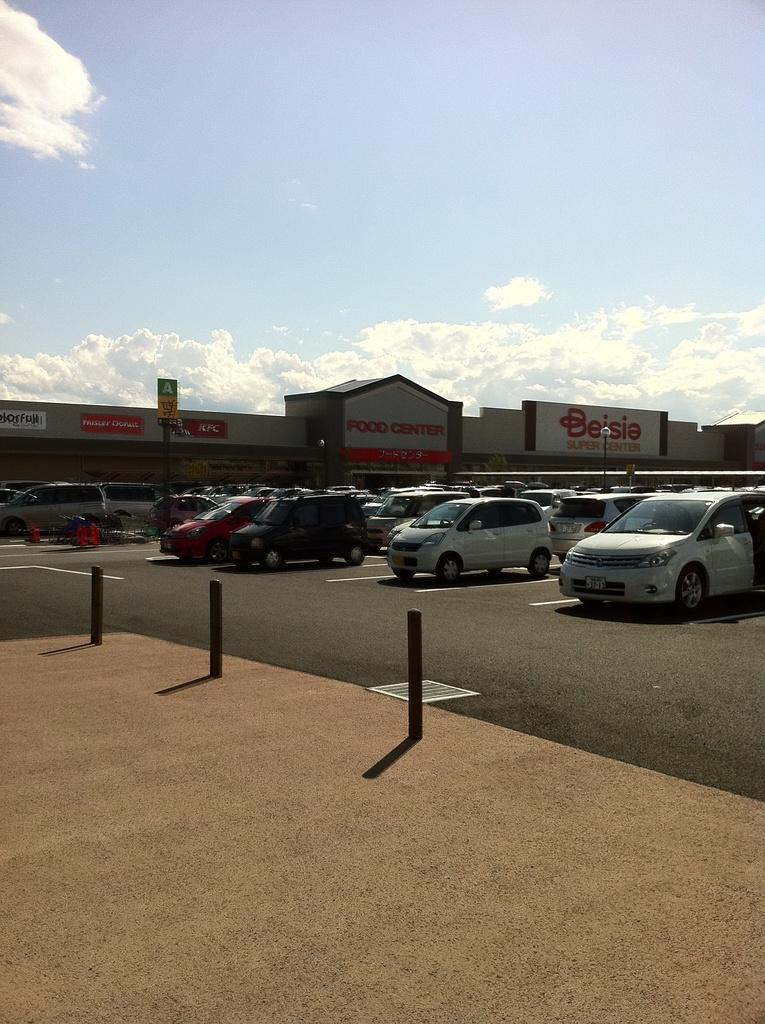What types of objects are present in the image? There are vehicles and a building in the image. What else can be seen in the image besides the vehicles and building? There are boards in the image. What can be seen in the background of the image? The sky is visible in the background of the image. How many toes can be seen on the grandfather's foot in the image? There is no grandfather or foot present in the image. 